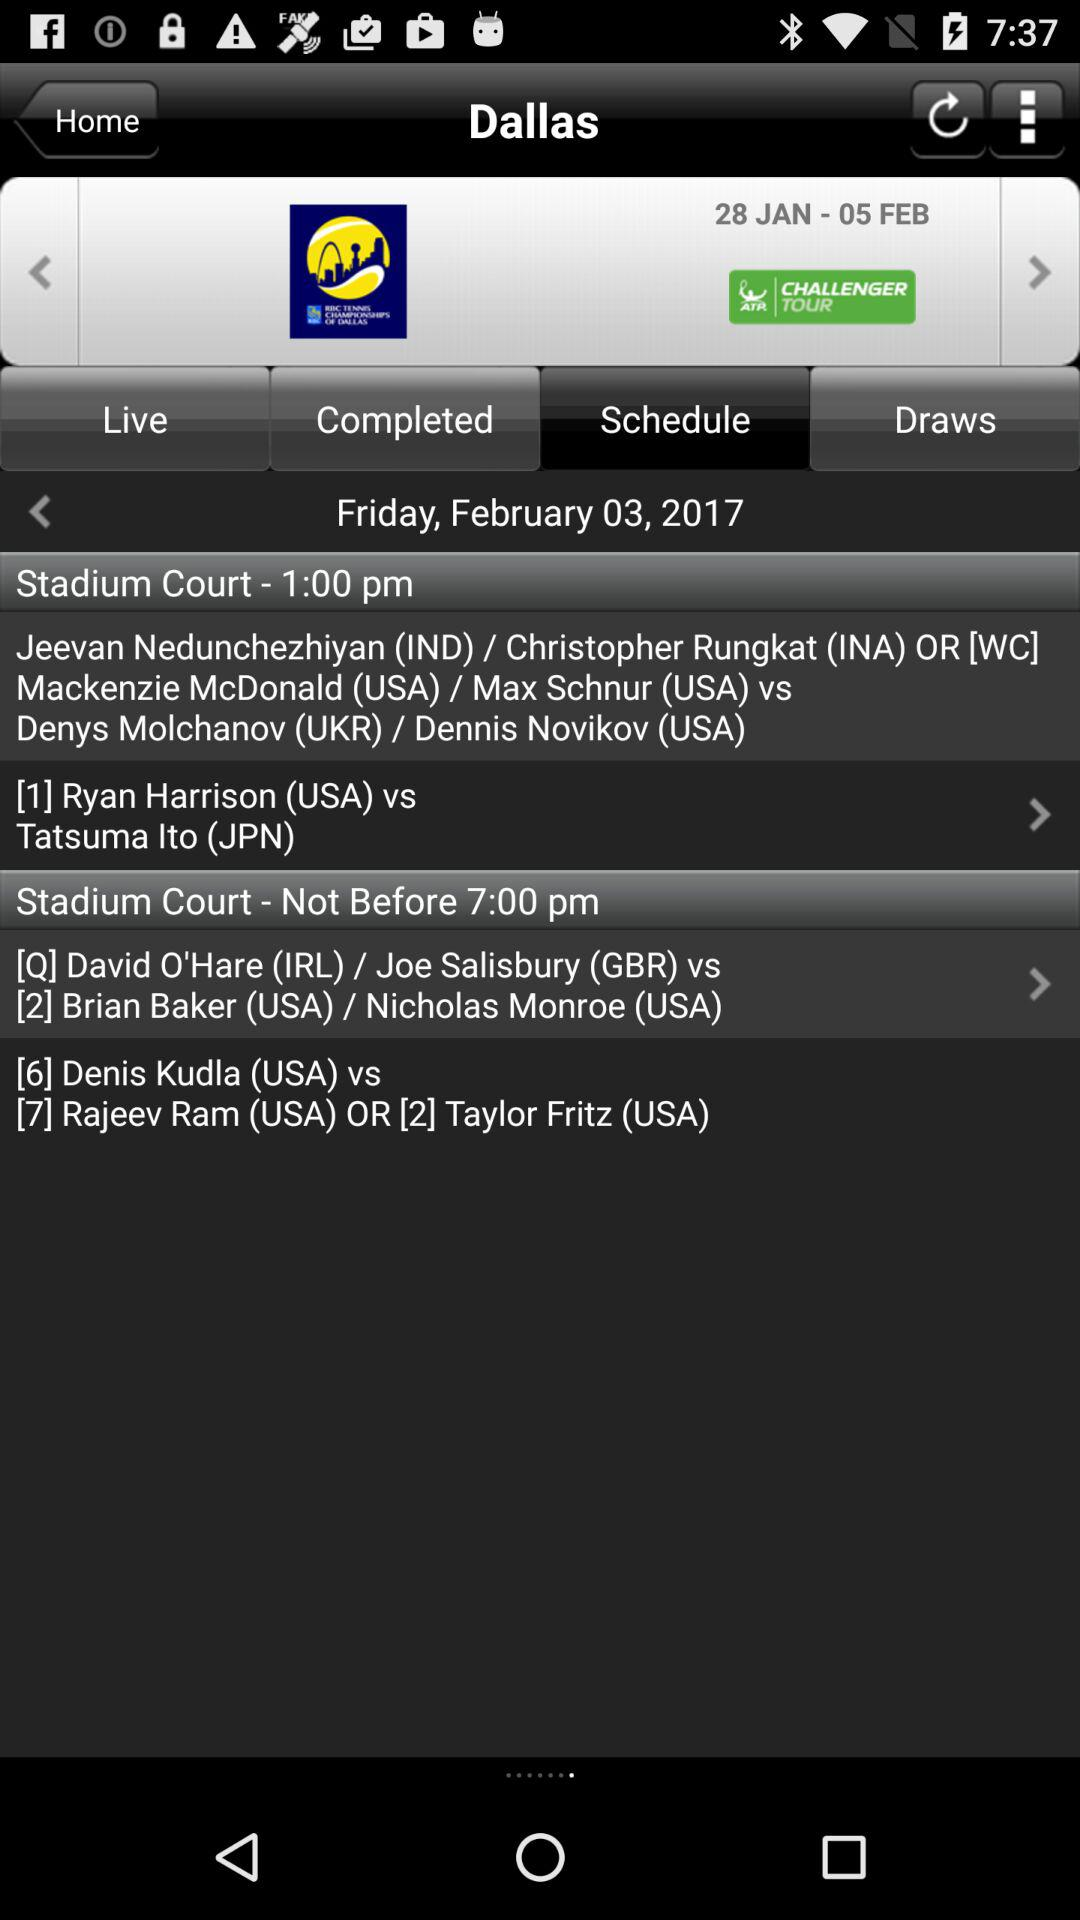What is the mentioned date? The mentioned date is Friday, February 3, 2017. 